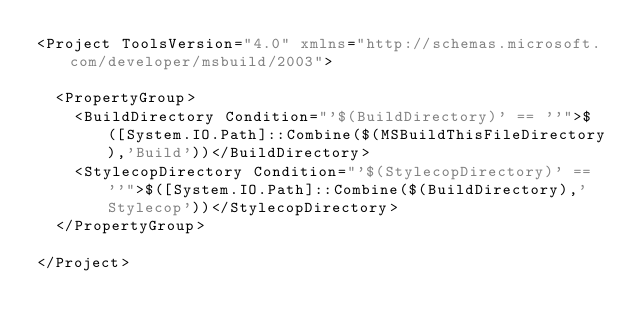<code> <loc_0><loc_0><loc_500><loc_500><_XML_><Project ToolsVersion="4.0" xmlns="http://schemas.microsoft.com/developer/msbuild/2003">

	<PropertyGroup>
		<BuildDirectory Condition="'$(BuildDirectory)' == ''">$([System.IO.Path]::Combine($(MSBuildThisFileDirectory),'Build'))</BuildDirectory>
		<StylecopDirectory Condition="'$(StylecopDirectory)' == ''">$([System.IO.Path]::Combine($(BuildDirectory),'Stylecop'))</StylecopDirectory>
	</PropertyGroup>

</Project></code> 